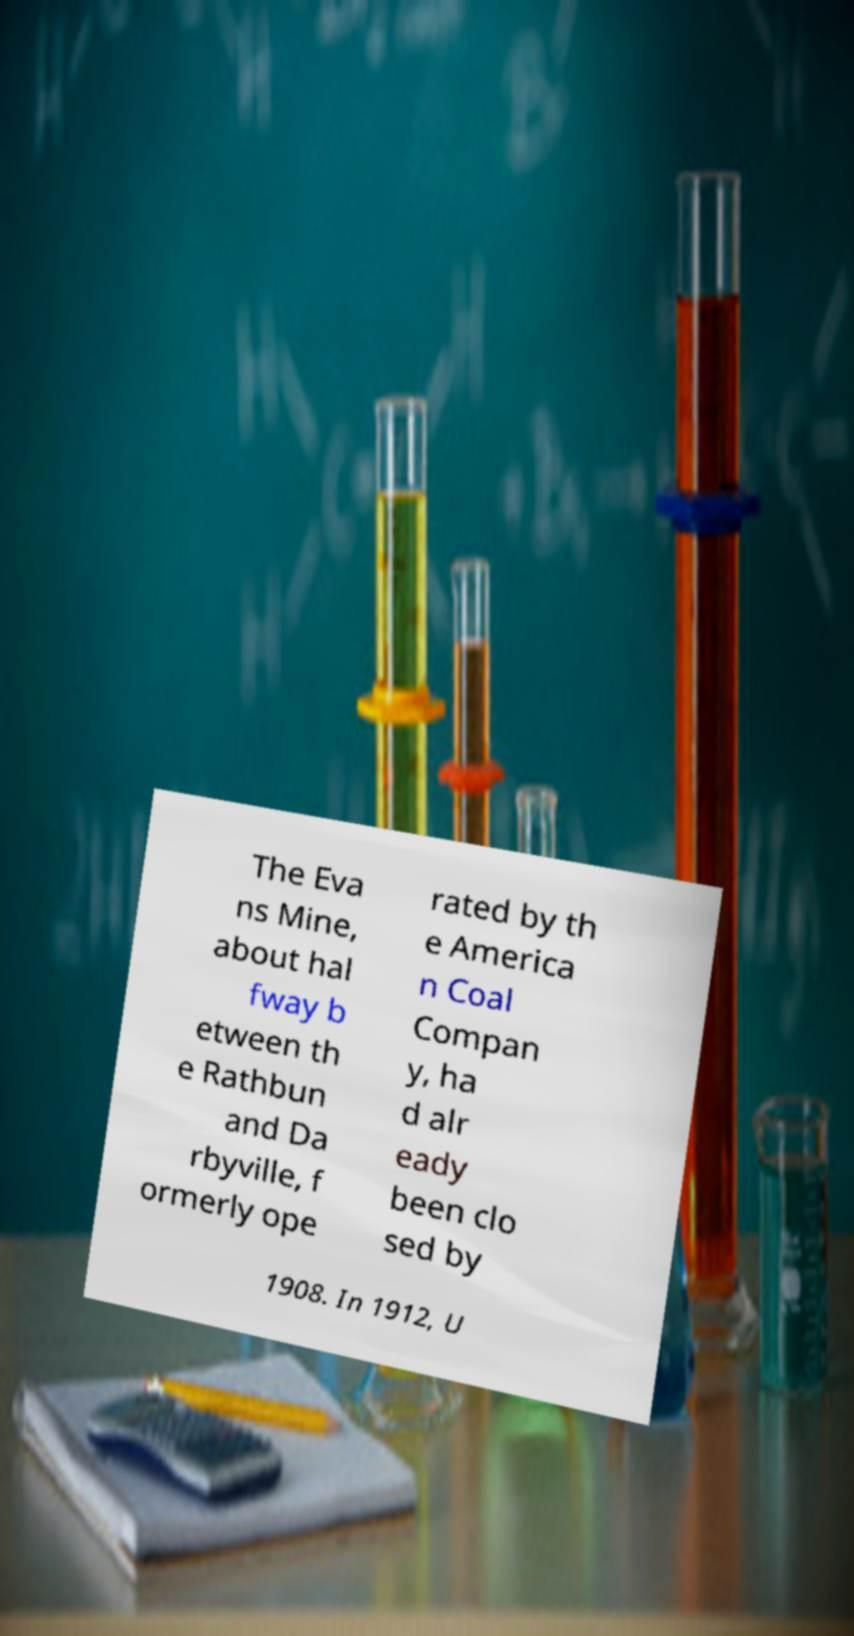Please identify and transcribe the text found in this image. The Eva ns Mine, about hal fway b etween th e Rathbun and Da rbyville, f ormerly ope rated by th e America n Coal Compan y, ha d alr eady been clo sed by 1908. In 1912, U 